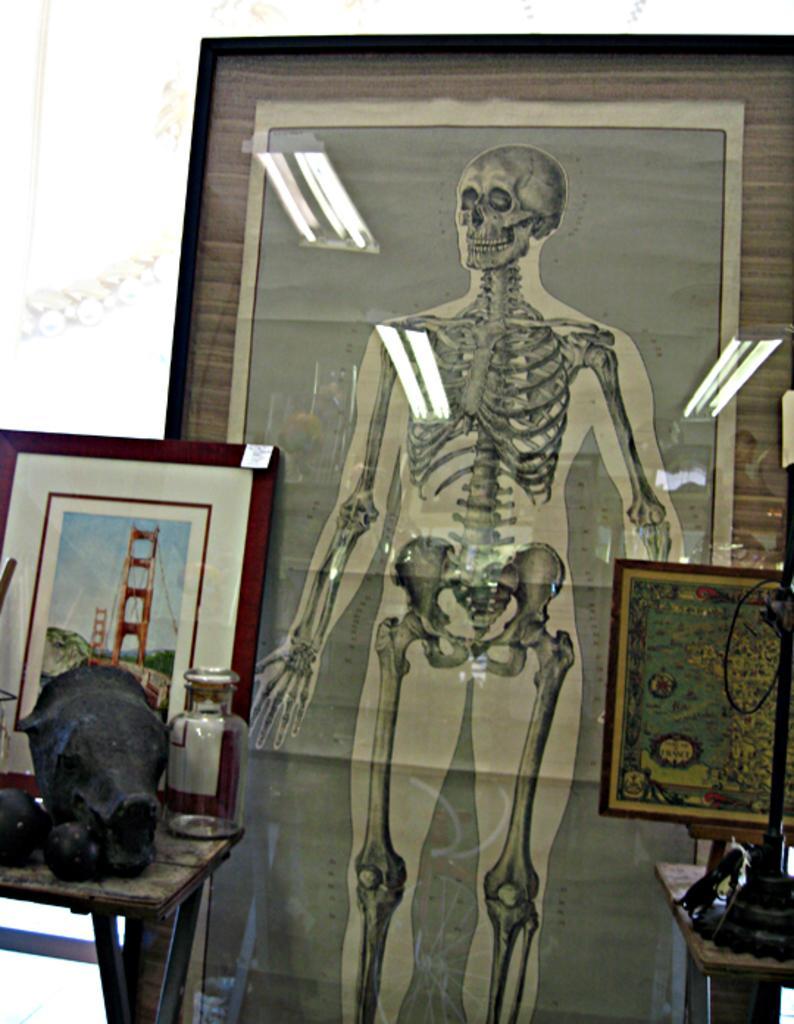Please provide a concise description of this image. In the right side it's an image of a human skeleton system. On the left side there is a photograph of a London bridge. 